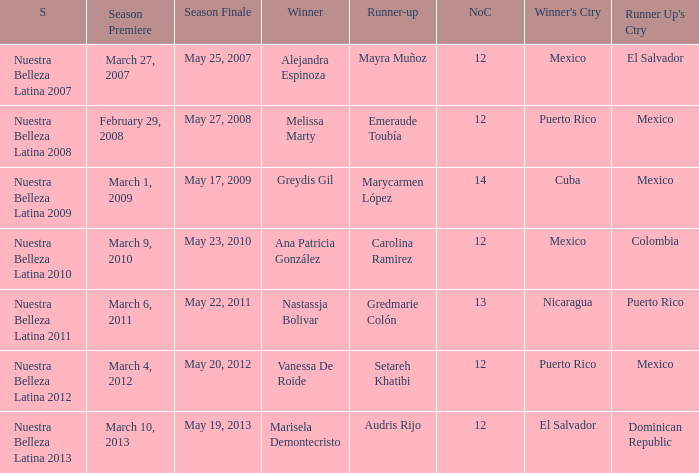How many contestants were there on March 1, 2009 during the season premiere? 14.0. 